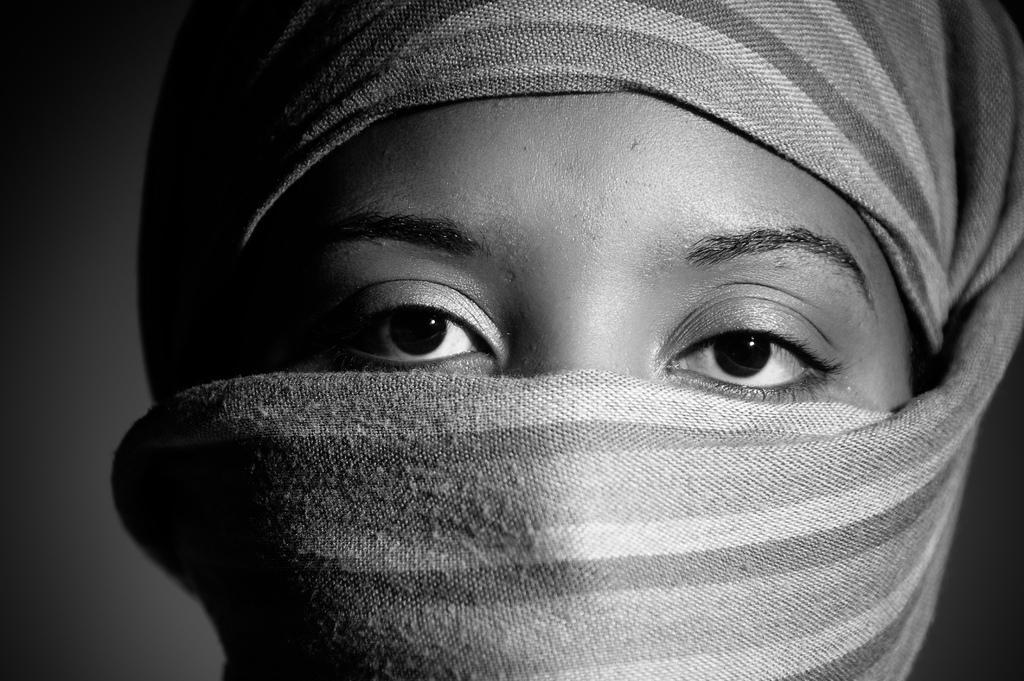Could you give a brief overview of what you see in this image? This is a black and white image, in this image there is a lady wearing mask. 